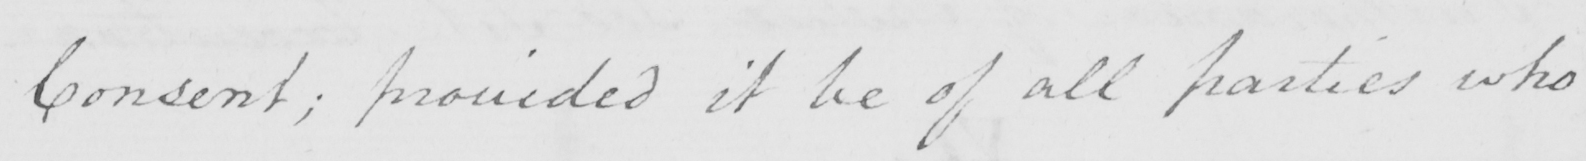What is written in this line of handwriting? Consent ; provided it be of all parties who 